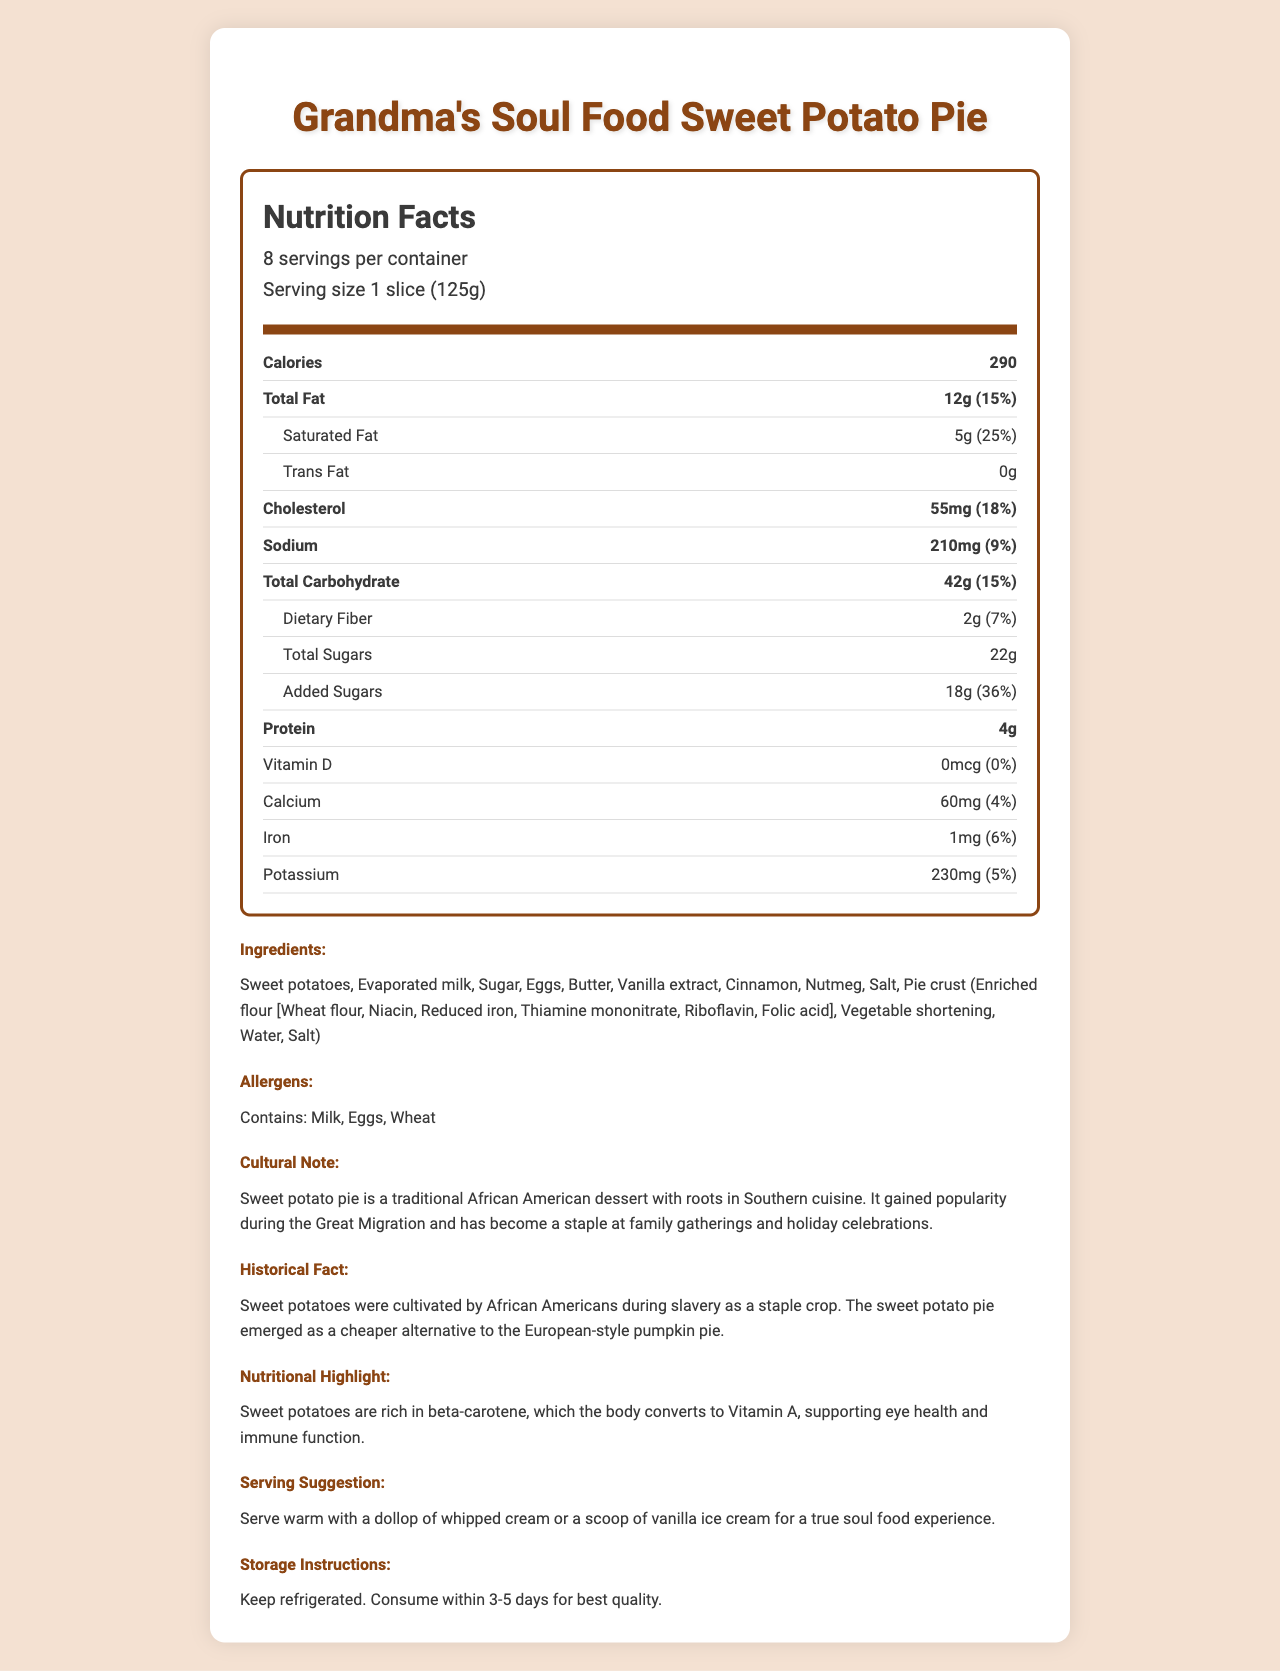What is the serving size for Grandma's Soul Food Sweet Potato Pie? The document specifies the serving size as "1 slice (125g)".
Answer: 1 slice (125g) How many servings are there per container? The document states that there are 8 servings per container.
Answer: 8 How many calories are in one serving of sweet potato pie? The calorie count for one serving is listed as 290 calories.
Answer: 290 What is the dietary fiber content per serving? The dietary fiber per serving is listed as 2g.
Answer: 2g List three main ingredients in Grandma's Soul Food Sweet Potato Pie. These are listed as the primary ingredients in the ingredients section.
Answer: Sweet potatoes, Evaporated milk, Sugar What percentage of the Daily Value of saturated fat does one serving provide? The document lists saturated fat as 5g, which is 25% of the daily value.
Answer: 25% What are the allergens mentioned in this product? The document explicitly states these three allergens.
Answer: Milk, Eggs, Wheat Which vitamin is highlighted as being abundant in sweet potatoes? A. Vitamin C B. Vitamin D C. Vitamin A D. Vitamin B12 The nutritional highlight mentions that sweet potatoes are rich in beta-carotene, which the body converts to Vitamin A, supporting eye health and immune function.
Answer: C. Vitamin A Which nutritional element has the highest percentage of the Daily Value per serving? A. Sodium B. Added Sugars C. Cholesterol D. Vitamin D Added sugars have 36% of the daily value, which is the highest percentage listed in the document.
Answer: B. Added Sugars True or False: Sweet potato pie is eaten warm for a typical soul food experience. The serving suggestion recommends serving the pie warm with a dollop of whipped cream or vanilla ice cream for a true soul food experience.
Answer: True What is the main cultural note about sweet potato pie? The cultural note section provides this information about the dessert.
Answer: It is a traditional African American dessert with roots in Southern cuisine. Cannot be determined based on this document The document does not provide information about the Vitamin C content.
Answer: How many grams of Vitamin C are in one slice? Summarize the nutritional and cultural significance of Grandma's Soul Food Sweet Potato Pie. This summary encapsulates the main nutritional information, cultural and historical significance, serving suggestion, and storage instructions.
Answer: Grandma's Soul Food Sweet Potato Pie, with a serving size of 1 slice (125g) and 290 calories per serving, offers a traditional African American dessert rich in history and culture. The pie includes key ingredients such as sweet potatoes, evaporated milk, and sugar, and contains common allergens like milk, eggs, and wheat. It has notable nutritional aspects, including being a source of beta-carotene (Vitamin A). The dessert is culturally significant, having gained popularity during the Great Migration and is a staple at family and holiday gatherings. The pie is best enjoyed warm and should be kept refrigerated. 